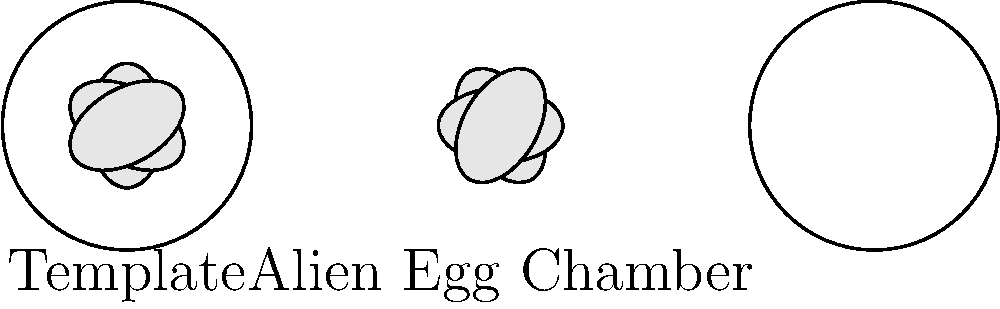In the Alien universe, you've discovered a chamber containing xenomorph eggs. The left diagram shows the template arrangement, while the right shows the current arrangement in the chamber. How many degrees clockwise should the entire egg pattern be rotated to match the template? To solve this problem, we need to follow these steps:

1. Observe the orientation of eggs in both the template and the chamber.
2. Identify a reference point to compare the rotations.
3. Calculate the angle difference between the template and the chamber.

Step 1: Observation
- The template shows eggs aligned at 0°, 60°, 120°, 180°, 240°, and 300°.
- The chamber shows eggs aligned at 30°, 90°, 150°, 210°, 270°, and 330°.

Step 2: Reference Point
Let's use the topmost egg as our reference point:
- In the template, it's at 0°.
- In the chamber, it's at 30°.

Step 3: Angle Calculation
- The difference between the chamber and the template is 30°.
- To match the template, we need to rotate the chamber pattern clockwise.
- The required rotation is 30° clockwise.

This rotation will align all eggs in the chamber with their corresponding positions in the template.
Answer: 30° 